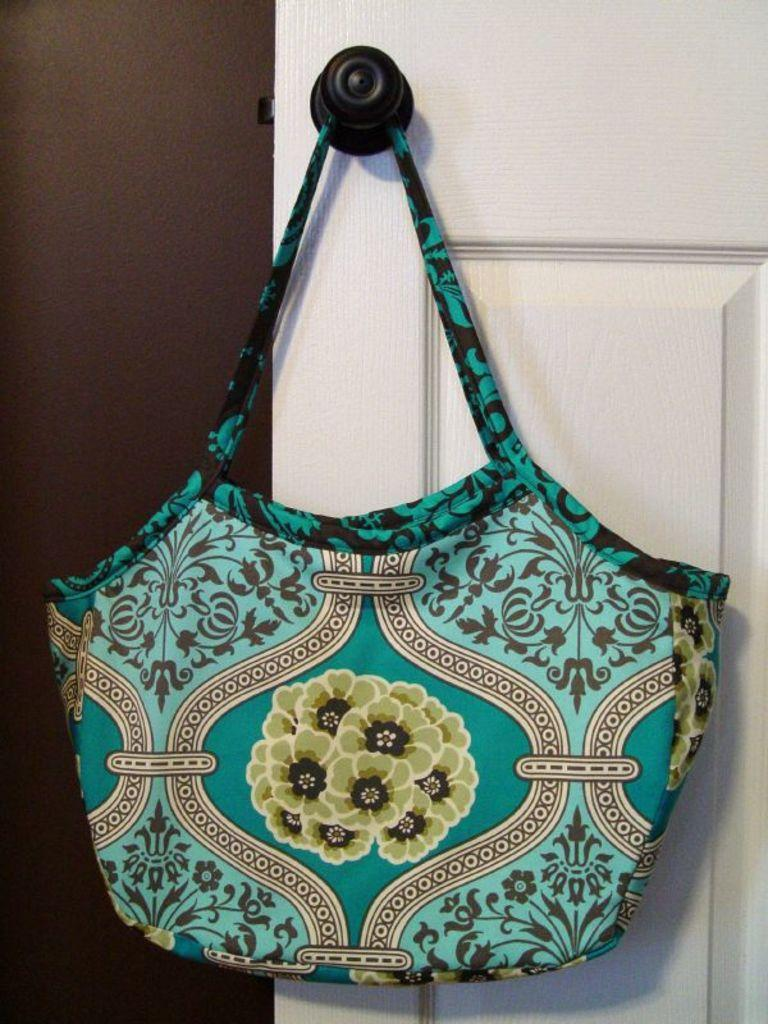What object is visible in the image? There is a handbag in the image. What feature can be seen on the door in the image? There is a door with a handle in the image. What type of structure is on the left side of the image? There is a wall on the left side of the image. What news is being discussed in the image? There is no indication of a news discussion or any news being present in the image. What type of adjustment is being made to the handbag in the image? There is no adjustment being made to the handbag in the image; it is stationary. 